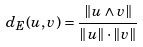<formula> <loc_0><loc_0><loc_500><loc_500>d _ { E } ( u , v ) = \frac { \| u \wedge v \| } { \| u \| \cdot \| v \| }</formula> 